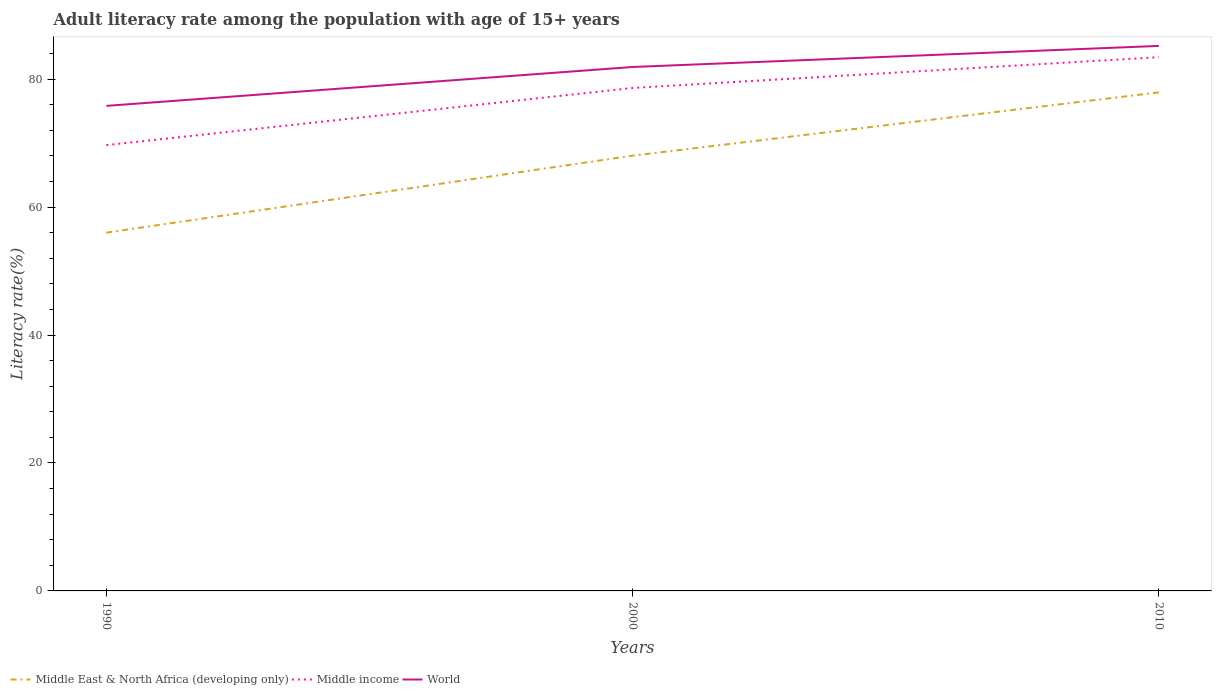Does the line corresponding to World intersect with the line corresponding to Middle East & North Africa (developing only)?
Give a very brief answer. No. Is the number of lines equal to the number of legend labels?
Your response must be concise. Yes. Across all years, what is the maximum adult literacy rate in World?
Your answer should be very brief. 75.83. In which year was the adult literacy rate in Middle income maximum?
Provide a short and direct response. 1990. What is the total adult literacy rate in World in the graph?
Your answer should be very brief. -3.29. What is the difference between the highest and the second highest adult literacy rate in Middle income?
Your response must be concise. 13.75. What is the difference between the highest and the lowest adult literacy rate in World?
Your response must be concise. 2. What is the difference between two consecutive major ticks on the Y-axis?
Ensure brevity in your answer.  20. Does the graph contain grids?
Ensure brevity in your answer.  No. How many legend labels are there?
Your answer should be compact. 3. How are the legend labels stacked?
Make the answer very short. Horizontal. What is the title of the graph?
Offer a very short reply. Adult literacy rate among the population with age of 15+ years. What is the label or title of the X-axis?
Provide a succinct answer. Years. What is the label or title of the Y-axis?
Your answer should be compact. Literacy rate(%). What is the Literacy rate(%) in Middle East & North Africa (developing only) in 1990?
Offer a terse response. 56.01. What is the Literacy rate(%) in Middle income in 1990?
Offer a very short reply. 69.69. What is the Literacy rate(%) in World in 1990?
Your answer should be very brief. 75.83. What is the Literacy rate(%) in Middle East & North Africa (developing only) in 2000?
Ensure brevity in your answer.  68.05. What is the Literacy rate(%) in Middle income in 2000?
Your response must be concise. 78.63. What is the Literacy rate(%) of World in 2000?
Make the answer very short. 81.91. What is the Literacy rate(%) of Middle East & North Africa (developing only) in 2010?
Ensure brevity in your answer.  77.94. What is the Literacy rate(%) in Middle income in 2010?
Ensure brevity in your answer.  83.44. What is the Literacy rate(%) in World in 2010?
Your response must be concise. 85.2. Across all years, what is the maximum Literacy rate(%) of Middle East & North Africa (developing only)?
Offer a terse response. 77.94. Across all years, what is the maximum Literacy rate(%) of Middle income?
Provide a succinct answer. 83.44. Across all years, what is the maximum Literacy rate(%) in World?
Provide a succinct answer. 85.2. Across all years, what is the minimum Literacy rate(%) in Middle East & North Africa (developing only)?
Ensure brevity in your answer.  56.01. Across all years, what is the minimum Literacy rate(%) in Middle income?
Offer a very short reply. 69.69. Across all years, what is the minimum Literacy rate(%) of World?
Offer a very short reply. 75.83. What is the total Literacy rate(%) of Middle East & North Africa (developing only) in the graph?
Your answer should be very brief. 201.99. What is the total Literacy rate(%) in Middle income in the graph?
Make the answer very short. 231.76. What is the total Literacy rate(%) of World in the graph?
Your answer should be very brief. 242.94. What is the difference between the Literacy rate(%) of Middle East & North Africa (developing only) in 1990 and that in 2000?
Your answer should be compact. -12.04. What is the difference between the Literacy rate(%) in Middle income in 1990 and that in 2000?
Keep it short and to the point. -8.94. What is the difference between the Literacy rate(%) in World in 1990 and that in 2000?
Your answer should be compact. -6.08. What is the difference between the Literacy rate(%) in Middle East & North Africa (developing only) in 1990 and that in 2010?
Make the answer very short. -21.93. What is the difference between the Literacy rate(%) of Middle income in 1990 and that in 2010?
Provide a short and direct response. -13.75. What is the difference between the Literacy rate(%) of World in 1990 and that in 2010?
Provide a short and direct response. -9.37. What is the difference between the Literacy rate(%) in Middle East & North Africa (developing only) in 2000 and that in 2010?
Provide a succinct answer. -9.89. What is the difference between the Literacy rate(%) of Middle income in 2000 and that in 2010?
Your response must be concise. -4.81. What is the difference between the Literacy rate(%) of World in 2000 and that in 2010?
Offer a terse response. -3.29. What is the difference between the Literacy rate(%) of Middle East & North Africa (developing only) in 1990 and the Literacy rate(%) of Middle income in 2000?
Your response must be concise. -22.62. What is the difference between the Literacy rate(%) in Middle East & North Africa (developing only) in 1990 and the Literacy rate(%) in World in 2000?
Your response must be concise. -25.9. What is the difference between the Literacy rate(%) in Middle income in 1990 and the Literacy rate(%) in World in 2000?
Your answer should be compact. -12.21. What is the difference between the Literacy rate(%) of Middle East & North Africa (developing only) in 1990 and the Literacy rate(%) of Middle income in 2010?
Your response must be concise. -27.43. What is the difference between the Literacy rate(%) in Middle East & North Africa (developing only) in 1990 and the Literacy rate(%) in World in 2010?
Offer a very short reply. -29.2. What is the difference between the Literacy rate(%) in Middle income in 1990 and the Literacy rate(%) in World in 2010?
Offer a very short reply. -15.51. What is the difference between the Literacy rate(%) of Middle East & North Africa (developing only) in 2000 and the Literacy rate(%) of Middle income in 2010?
Give a very brief answer. -15.39. What is the difference between the Literacy rate(%) of Middle East & North Africa (developing only) in 2000 and the Literacy rate(%) of World in 2010?
Provide a short and direct response. -17.16. What is the difference between the Literacy rate(%) in Middle income in 2000 and the Literacy rate(%) in World in 2010?
Ensure brevity in your answer.  -6.57. What is the average Literacy rate(%) of Middle East & North Africa (developing only) per year?
Offer a terse response. 67.33. What is the average Literacy rate(%) in Middle income per year?
Provide a succinct answer. 77.25. What is the average Literacy rate(%) in World per year?
Your answer should be very brief. 80.98. In the year 1990, what is the difference between the Literacy rate(%) in Middle East & North Africa (developing only) and Literacy rate(%) in Middle income?
Provide a short and direct response. -13.69. In the year 1990, what is the difference between the Literacy rate(%) of Middle East & North Africa (developing only) and Literacy rate(%) of World?
Provide a succinct answer. -19.82. In the year 1990, what is the difference between the Literacy rate(%) of Middle income and Literacy rate(%) of World?
Make the answer very short. -6.14. In the year 2000, what is the difference between the Literacy rate(%) in Middle East & North Africa (developing only) and Literacy rate(%) in Middle income?
Make the answer very short. -10.58. In the year 2000, what is the difference between the Literacy rate(%) of Middle East & North Africa (developing only) and Literacy rate(%) of World?
Keep it short and to the point. -13.86. In the year 2000, what is the difference between the Literacy rate(%) in Middle income and Literacy rate(%) in World?
Make the answer very short. -3.28. In the year 2010, what is the difference between the Literacy rate(%) of Middle East & North Africa (developing only) and Literacy rate(%) of Middle income?
Offer a terse response. -5.5. In the year 2010, what is the difference between the Literacy rate(%) in Middle East & North Africa (developing only) and Literacy rate(%) in World?
Your answer should be very brief. -7.26. In the year 2010, what is the difference between the Literacy rate(%) of Middle income and Literacy rate(%) of World?
Give a very brief answer. -1.76. What is the ratio of the Literacy rate(%) in Middle East & North Africa (developing only) in 1990 to that in 2000?
Give a very brief answer. 0.82. What is the ratio of the Literacy rate(%) of Middle income in 1990 to that in 2000?
Ensure brevity in your answer.  0.89. What is the ratio of the Literacy rate(%) in World in 1990 to that in 2000?
Give a very brief answer. 0.93. What is the ratio of the Literacy rate(%) in Middle East & North Africa (developing only) in 1990 to that in 2010?
Provide a short and direct response. 0.72. What is the ratio of the Literacy rate(%) of Middle income in 1990 to that in 2010?
Your answer should be very brief. 0.84. What is the ratio of the Literacy rate(%) in World in 1990 to that in 2010?
Offer a terse response. 0.89. What is the ratio of the Literacy rate(%) of Middle East & North Africa (developing only) in 2000 to that in 2010?
Your answer should be very brief. 0.87. What is the ratio of the Literacy rate(%) in Middle income in 2000 to that in 2010?
Offer a terse response. 0.94. What is the ratio of the Literacy rate(%) of World in 2000 to that in 2010?
Keep it short and to the point. 0.96. What is the difference between the highest and the second highest Literacy rate(%) in Middle East & North Africa (developing only)?
Offer a terse response. 9.89. What is the difference between the highest and the second highest Literacy rate(%) in Middle income?
Your answer should be very brief. 4.81. What is the difference between the highest and the second highest Literacy rate(%) of World?
Your answer should be compact. 3.29. What is the difference between the highest and the lowest Literacy rate(%) in Middle East & North Africa (developing only)?
Offer a very short reply. 21.93. What is the difference between the highest and the lowest Literacy rate(%) of Middle income?
Provide a short and direct response. 13.75. What is the difference between the highest and the lowest Literacy rate(%) of World?
Offer a terse response. 9.37. 